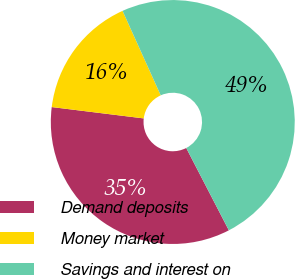Convert chart to OTSL. <chart><loc_0><loc_0><loc_500><loc_500><pie_chart><fcel>Demand deposits<fcel>Money market<fcel>Savings and interest on<nl><fcel>34.56%<fcel>16.29%<fcel>49.15%<nl></chart> 